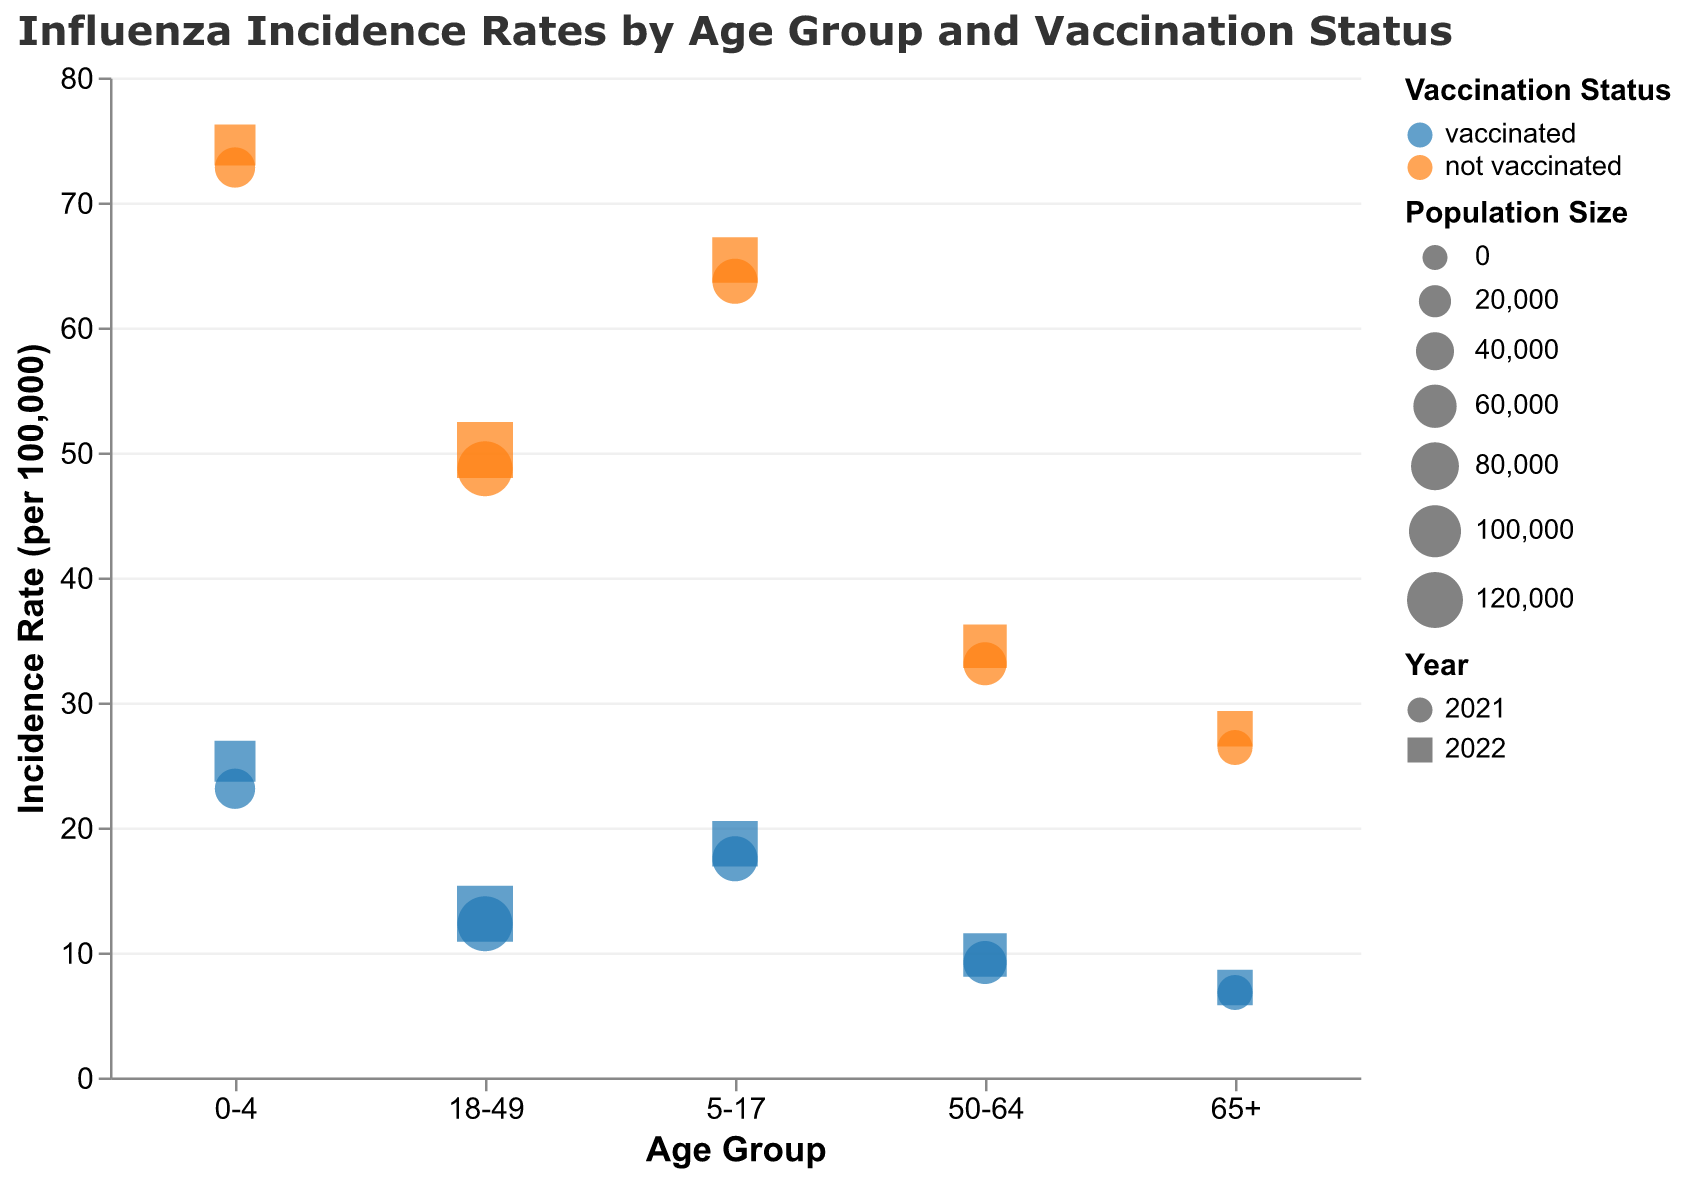What is the title of the figure? The title is usually placed at the top of the chart and describes the overall content.
Answer: Influenza Incidence Rates by Age Group and Vaccination Status Which age group has the highest incidence rate in 2022 for those not vaccinated? Look for the Age Group with the highest value in the "Incidence Rate" axis for the year 2022 with "not vaccinated" status.
Answer: 0-4 What is the incidence rate for the 50-64 age group in 2021 for vaccinated individuals? Find the data point corresponding to the 50-64 age group, year 2021, and vaccination status "vaccinated", then read off the "Incidence Rate".
Answer: 9.2 How does the incidence rate for the 18-49 age group in 2022 compare between vaccinated and not vaccinated individuals? Compare the "Incidence Rate" values for the 18-49 age group under the year 2022 for both vaccination statuses.
Answer: Not vaccinated individuals have a higher incidence rate (50.2) compared to vaccinated individuals (13.1) What is the difference in incidence rates between the vaccinated and not vaccinated groups for the 65+ age group in 2022? Find the "Incidence Rate" for both "vaccinated" and "not vaccinated" in the 65+ age group for 2022, then subtract the two values.
Answer: 20.7 Which age group in 2021 has the smallest difference in incidence rates between vaccinated and unvaccinated individuals? Calculate the differences in incidence rates between "vaccinated" and "not vaccinated" for each age group in 2021, then identify the smallest difference.
Answer: 65+ What is the total population size for the 5-17 age group in 2021? Sum the "Population Size" for both vaccinated and not vaccinated individuals in the 5-17 age group for 2021.
Answer: 136,000 How has the incidence rate for the 0-4 age group changed from 2021 to 2022 for those not vaccinated? Compare the "Incidence Rate" for the 0-4 age group with "not vaccinated" status between the years 2021 and 2022.
Answer: It increased from 72.8 to 74.6 What is the average incidence rate for vaccinated individuals in 2022 across all age groups? Sum the incidence rates for all vaccinated individuals in 2022, then divide by the number of age groups (five).
Answer: (25.3 + 18.7 + 13.1 + 9.8 + 7.2) / 5 = 14.82 Which age group had the highest population size in 2022? Compare the "Population Size" for each age group in 2022 to determine the highest value.
Answer: 18-49 